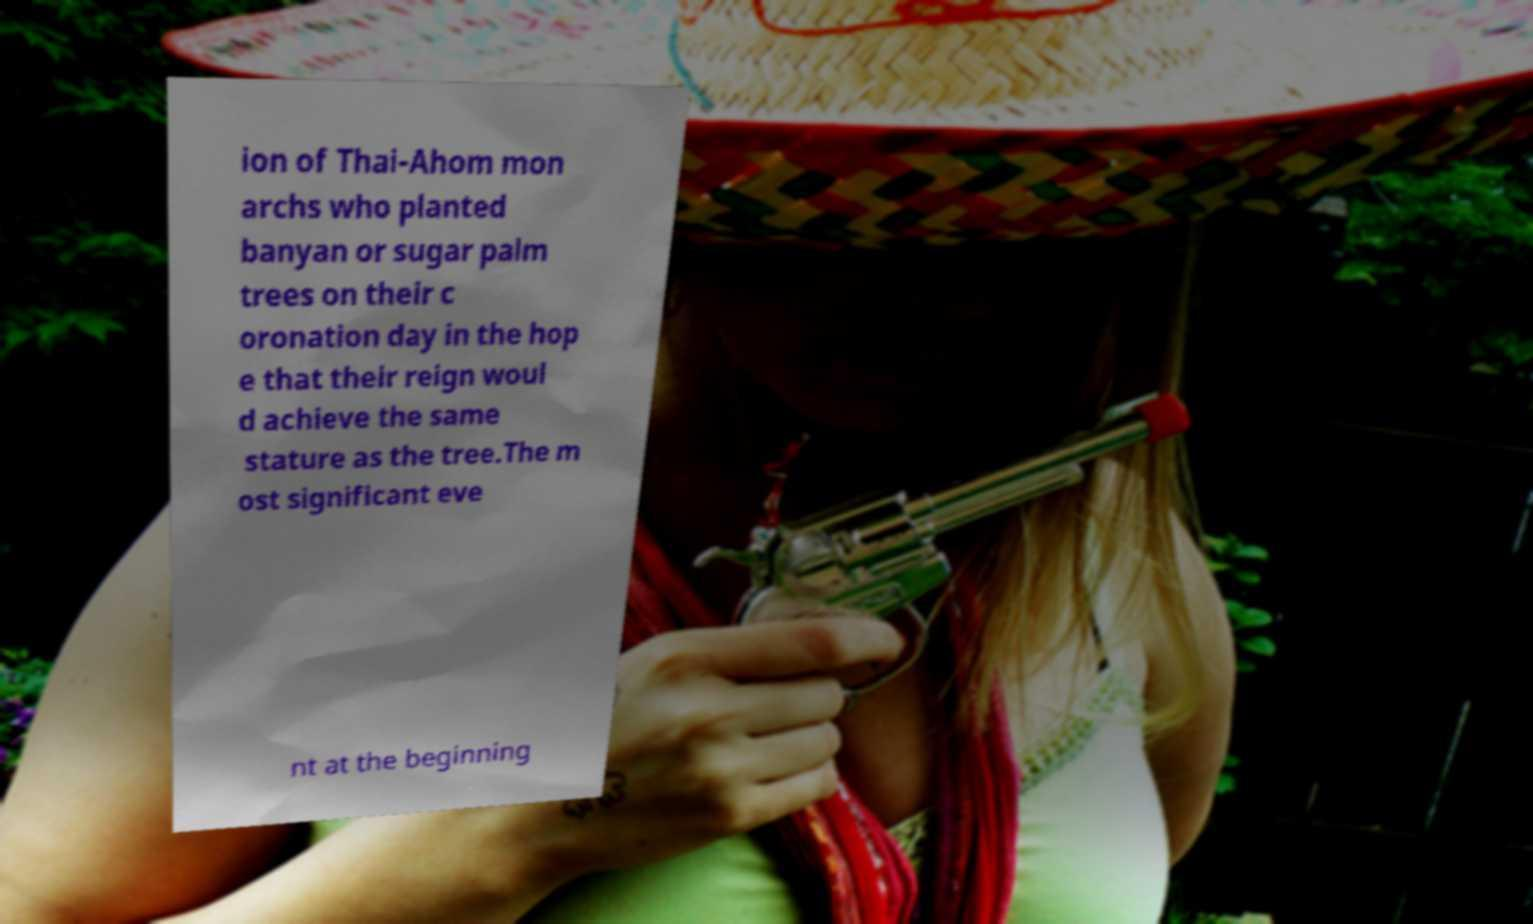Could you extract and type out the text from this image? ion of Thai-Ahom mon archs who planted banyan or sugar palm trees on their c oronation day in the hop e that their reign woul d achieve the same stature as the tree.The m ost significant eve nt at the beginning 